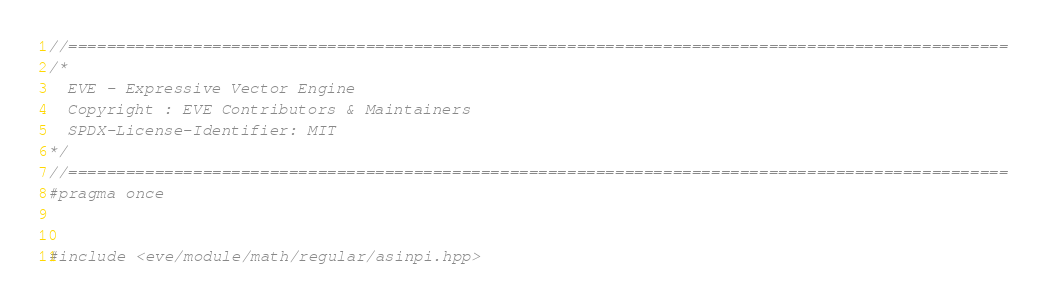Convert code to text. <code><loc_0><loc_0><loc_500><loc_500><_C++_>//==================================================================================================
/*
  EVE - Expressive Vector Engine
  Copyright : EVE Contributors & Maintainers
  SPDX-License-Identifier: MIT
*/
//==================================================================================================
#pragma once


#include <eve/module/math/regular/asinpi.hpp>
</code> 